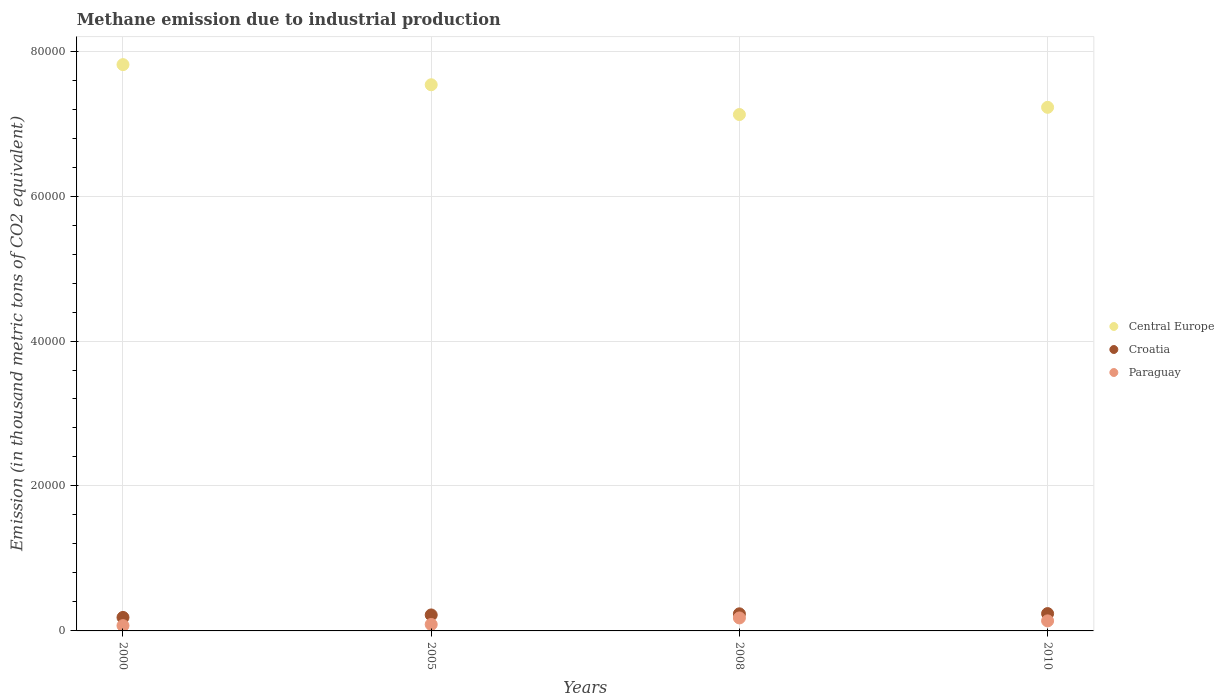Is the number of dotlines equal to the number of legend labels?
Keep it short and to the point. Yes. What is the amount of methane emitted in Croatia in 2005?
Offer a terse response. 2204.5. Across all years, what is the maximum amount of methane emitted in Central Europe?
Offer a terse response. 7.81e+04. Across all years, what is the minimum amount of methane emitted in Central Europe?
Your answer should be compact. 7.12e+04. In which year was the amount of methane emitted in Paraguay minimum?
Provide a short and direct response. 2000. What is the total amount of methane emitted in Croatia in the graph?
Provide a succinct answer. 8814.7. What is the difference between the amount of methane emitted in Paraguay in 2000 and that in 2005?
Your response must be concise. -161.7. What is the difference between the amount of methane emitted in Croatia in 2005 and the amount of methane emitted in Paraguay in 2008?
Your answer should be very brief. 413.8. What is the average amount of methane emitted in Croatia per year?
Offer a very short reply. 2203.68. In the year 2005, what is the difference between the amount of methane emitted in Central Europe and amount of methane emitted in Paraguay?
Your response must be concise. 7.45e+04. In how many years, is the amount of methane emitted in Paraguay greater than 76000 thousand metric tons?
Offer a terse response. 0. What is the ratio of the amount of methane emitted in Croatia in 2005 to that in 2008?
Provide a succinct answer. 0.93. Is the difference between the amount of methane emitted in Central Europe in 2008 and 2010 greater than the difference between the amount of methane emitted in Paraguay in 2008 and 2010?
Provide a short and direct response. No. What is the difference between the highest and the second highest amount of methane emitted in Paraguay?
Make the answer very short. 404.5. What is the difference between the highest and the lowest amount of methane emitted in Croatia?
Your answer should be very brief. 527.6. In how many years, is the amount of methane emitted in Central Europe greater than the average amount of methane emitted in Central Europe taken over all years?
Keep it short and to the point. 2. Does the amount of methane emitted in Paraguay monotonically increase over the years?
Give a very brief answer. No. How many dotlines are there?
Your answer should be compact. 3. What is the difference between two consecutive major ticks on the Y-axis?
Keep it short and to the point. 2.00e+04. Are the values on the major ticks of Y-axis written in scientific E-notation?
Your response must be concise. No. Where does the legend appear in the graph?
Your answer should be compact. Center right. How are the legend labels stacked?
Offer a terse response. Vertical. What is the title of the graph?
Offer a very short reply. Methane emission due to industrial production. What is the label or title of the X-axis?
Your answer should be very brief. Years. What is the label or title of the Y-axis?
Your answer should be very brief. Emission (in thousand metric tons of CO2 equivalent). What is the Emission (in thousand metric tons of CO2 equivalent) in Central Europe in 2000?
Ensure brevity in your answer.  7.81e+04. What is the Emission (in thousand metric tons of CO2 equivalent) of Croatia in 2000?
Your answer should be compact. 1861.7. What is the Emission (in thousand metric tons of CO2 equivalent) in Paraguay in 2000?
Make the answer very short. 730.2. What is the Emission (in thousand metric tons of CO2 equivalent) in Central Europe in 2005?
Give a very brief answer. 7.54e+04. What is the Emission (in thousand metric tons of CO2 equivalent) of Croatia in 2005?
Keep it short and to the point. 2204.5. What is the Emission (in thousand metric tons of CO2 equivalent) in Paraguay in 2005?
Offer a terse response. 891.9. What is the Emission (in thousand metric tons of CO2 equivalent) in Central Europe in 2008?
Provide a short and direct response. 7.12e+04. What is the Emission (in thousand metric tons of CO2 equivalent) of Croatia in 2008?
Make the answer very short. 2359.2. What is the Emission (in thousand metric tons of CO2 equivalent) of Paraguay in 2008?
Keep it short and to the point. 1790.7. What is the Emission (in thousand metric tons of CO2 equivalent) of Central Europe in 2010?
Give a very brief answer. 7.22e+04. What is the Emission (in thousand metric tons of CO2 equivalent) of Croatia in 2010?
Offer a very short reply. 2389.3. What is the Emission (in thousand metric tons of CO2 equivalent) in Paraguay in 2010?
Keep it short and to the point. 1386.2. Across all years, what is the maximum Emission (in thousand metric tons of CO2 equivalent) in Central Europe?
Give a very brief answer. 7.81e+04. Across all years, what is the maximum Emission (in thousand metric tons of CO2 equivalent) in Croatia?
Your response must be concise. 2389.3. Across all years, what is the maximum Emission (in thousand metric tons of CO2 equivalent) in Paraguay?
Make the answer very short. 1790.7. Across all years, what is the minimum Emission (in thousand metric tons of CO2 equivalent) in Central Europe?
Your answer should be very brief. 7.12e+04. Across all years, what is the minimum Emission (in thousand metric tons of CO2 equivalent) of Croatia?
Keep it short and to the point. 1861.7. Across all years, what is the minimum Emission (in thousand metric tons of CO2 equivalent) in Paraguay?
Provide a succinct answer. 730.2. What is the total Emission (in thousand metric tons of CO2 equivalent) of Central Europe in the graph?
Provide a short and direct response. 2.97e+05. What is the total Emission (in thousand metric tons of CO2 equivalent) of Croatia in the graph?
Provide a short and direct response. 8814.7. What is the total Emission (in thousand metric tons of CO2 equivalent) of Paraguay in the graph?
Your response must be concise. 4799. What is the difference between the Emission (in thousand metric tons of CO2 equivalent) in Central Europe in 2000 and that in 2005?
Provide a short and direct response. 2778.4. What is the difference between the Emission (in thousand metric tons of CO2 equivalent) in Croatia in 2000 and that in 2005?
Ensure brevity in your answer.  -342.8. What is the difference between the Emission (in thousand metric tons of CO2 equivalent) in Paraguay in 2000 and that in 2005?
Your answer should be very brief. -161.7. What is the difference between the Emission (in thousand metric tons of CO2 equivalent) of Central Europe in 2000 and that in 2008?
Offer a very short reply. 6887.3. What is the difference between the Emission (in thousand metric tons of CO2 equivalent) in Croatia in 2000 and that in 2008?
Your answer should be compact. -497.5. What is the difference between the Emission (in thousand metric tons of CO2 equivalent) of Paraguay in 2000 and that in 2008?
Ensure brevity in your answer.  -1060.5. What is the difference between the Emission (in thousand metric tons of CO2 equivalent) in Central Europe in 2000 and that in 2010?
Give a very brief answer. 5890.9. What is the difference between the Emission (in thousand metric tons of CO2 equivalent) in Croatia in 2000 and that in 2010?
Offer a terse response. -527.6. What is the difference between the Emission (in thousand metric tons of CO2 equivalent) of Paraguay in 2000 and that in 2010?
Give a very brief answer. -656. What is the difference between the Emission (in thousand metric tons of CO2 equivalent) of Central Europe in 2005 and that in 2008?
Ensure brevity in your answer.  4108.9. What is the difference between the Emission (in thousand metric tons of CO2 equivalent) of Croatia in 2005 and that in 2008?
Provide a succinct answer. -154.7. What is the difference between the Emission (in thousand metric tons of CO2 equivalent) of Paraguay in 2005 and that in 2008?
Offer a terse response. -898.8. What is the difference between the Emission (in thousand metric tons of CO2 equivalent) of Central Europe in 2005 and that in 2010?
Keep it short and to the point. 3112.5. What is the difference between the Emission (in thousand metric tons of CO2 equivalent) in Croatia in 2005 and that in 2010?
Provide a short and direct response. -184.8. What is the difference between the Emission (in thousand metric tons of CO2 equivalent) in Paraguay in 2005 and that in 2010?
Offer a very short reply. -494.3. What is the difference between the Emission (in thousand metric tons of CO2 equivalent) of Central Europe in 2008 and that in 2010?
Offer a terse response. -996.4. What is the difference between the Emission (in thousand metric tons of CO2 equivalent) in Croatia in 2008 and that in 2010?
Offer a terse response. -30.1. What is the difference between the Emission (in thousand metric tons of CO2 equivalent) in Paraguay in 2008 and that in 2010?
Provide a short and direct response. 404.5. What is the difference between the Emission (in thousand metric tons of CO2 equivalent) of Central Europe in 2000 and the Emission (in thousand metric tons of CO2 equivalent) of Croatia in 2005?
Make the answer very short. 7.59e+04. What is the difference between the Emission (in thousand metric tons of CO2 equivalent) in Central Europe in 2000 and the Emission (in thousand metric tons of CO2 equivalent) in Paraguay in 2005?
Offer a very short reply. 7.72e+04. What is the difference between the Emission (in thousand metric tons of CO2 equivalent) of Croatia in 2000 and the Emission (in thousand metric tons of CO2 equivalent) of Paraguay in 2005?
Provide a succinct answer. 969.8. What is the difference between the Emission (in thousand metric tons of CO2 equivalent) of Central Europe in 2000 and the Emission (in thousand metric tons of CO2 equivalent) of Croatia in 2008?
Keep it short and to the point. 7.58e+04. What is the difference between the Emission (in thousand metric tons of CO2 equivalent) in Central Europe in 2000 and the Emission (in thousand metric tons of CO2 equivalent) in Paraguay in 2008?
Provide a short and direct response. 7.63e+04. What is the difference between the Emission (in thousand metric tons of CO2 equivalent) in Central Europe in 2000 and the Emission (in thousand metric tons of CO2 equivalent) in Croatia in 2010?
Ensure brevity in your answer.  7.57e+04. What is the difference between the Emission (in thousand metric tons of CO2 equivalent) in Central Europe in 2000 and the Emission (in thousand metric tons of CO2 equivalent) in Paraguay in 2010?
Give a very brief answer. 7.67e+04. What is the difference between the Emission (in thousand metric tons of CO2 equivalent) of Croatia in 2000 and the Emission (in thousand metric tons of CO2 equivalent) of Paraguay in 2010?
Give a very brief answer. 475.5. What is the difference between the Emission (in thousand metric tons of CO2 equivalent) in Central Europe in 2005 and the Emission (in thousand metric tons of CO2 equivalent) in Croatia in 2008?
Ensure brevity in your answer.  7.30e+04. What is the difference between the Emission (in thousand metric tons of CO2 equivalent) of Central Europe in 2005 and the Emission (in thousand metric tons of CO2 equivalent) of Paraguay in 2008?
Ensure brevity in your answer.  7.36e+04. What is the difference between the Emission (in thousand metric tons of CO2 equivalent) of Croatia in 2005 and the Emission (in thousand metric tons of CO2 equivalent) of Paraguay in 2008?
Ensure brevity in your answer.  413.8. What is the difference between the Emission (in thousand metric tons of CO2 equivalent) of Central Europe in 2005 and the Emission (in thousand metric tons of CO2 equivalent) of Croatia in 2010?
Your response must be concise. 7.30e+04. What is the difference between the Emission (in thousand metric tons of CO2 equivalent) of Central Europe in 2005 and the Emission (in thousand metric tons of CO2 equivalent) of Paraguay in 2010?
Ensure brevity in your answer.  7.40e+04. What is the difference between the Emission (in thousand metric tons of CO2 equivalent) in Croatia in 2005 and the Emission (in thousand metric tons of CO2 equivalent) in Paraguay in 2010?
Offer a very short reply. 818.3. What is the difference between the Emission (in thousand metric tons of CO2 equivalent) in Central Europe in 2008 and the Emission (in thousand metric tons of CO2 equivalent) in Croatia in 2010?
Provide a succinct answer. 6.89e+04. What is the difference between the Emission (in thousand metric tons of CO2 equivalent) of Central Europe in 2008 and the Emission (in thousand metric tons of CO2 equivalent) of Paraguay in 2010?
Provide a succinct answer. 6.99e+04. What is the difference between the Emission (in thousand metric tons of CO2 equivalent) in Croatia in 2008 and the Emission (in thousand metric tons of CO2 equivalent) in Paraguay in 2010?
Make the answer very short. 973. What is the average Emission (in thousand metric tons of CO2 equivalent) in Central Europe per year?
Your response must be concise. 7.42e+04. What is the average Emission (in thousand metric tons of CO2 equivalent) in Croatia per year?
Ensure brevity in your answer.  2203.68. What is the average Emission (in thousand metric tons of CO2 equivalent) of Paraguay per year?
Make the answer very short. 1199.75. In the year 2000, what is the difference between the Emission (in thousand metric tons of CO2 equivalent) of Central Europe and Emission (in thousand metric tons of CO2 equivalent) of Croatia?
Your answer should be compact. 7.63e+04. In the year 2000, what is the difference between the Emission (in thousand metric tons of CO2 equivalent) of Central Europe and Emission (in thousand metric tons of CO2 equivalent) of Paraguay?
Offer a very short reply. 7.74e+04. In the year 2000, what is the difference between the Emission (in thousand metric tons of CO2 equivalent) in Croatia and Emission (in thousand metric tons of CO2 equivalent) in Paraguay?
Ensure brevity in your answer.  1131.5. In the year 2005, what is the difference between the Emission (in thousand metric tons of CO2 equivalent) in Central Europe and Emission (in thousand metric tons of CO2 equivalent) in Croatia?
Your answer should be compact. 7.32e+04. In the year 2005, what is the difference between the Emission (in thousand metric tons of CO2 equivalent) in Central Europe and Emission (in thousand metric tons of CO2 equivalent) in Paraguay?
Keep it short and to the point. 7.45e+04. In the year 2005, what is the difference between the Emission (in thousand metric tons of CO2 equivalent) in Croatia and Emission (in thousand metric tons of CO2 equivalent) in Paraguay?
Keep it short and to the point. 1312.6. In the year 2008, what is the difference between the Emission (in thousand metric tons of CO2 equivalent) of Central Europe and Emission (in thousand metric tons of CO2 equivalent) of Croatia?
Offer a terse response. 6.89e+04. In the year 2008, what is the difference between the Emission (in thousand metric tons of CO2 equivalent) in Central Europe and Emission (in thousand metric tons of CO2 equivalent) in Paraguay?
Your answer should be very brief. 6.95e+04. In the year 2008, what is the difference between the Emission (in thousand metric tons of CO2 equivalent) in Croatia and Emission (in thousand metric tons of CO2 equivalent) in Paraguay?
Make the answer very short. 568.5. In the year 2010, what is the difference between the Emission (in thousand metric tons of CO2 equivalent) in Central Europe and Emission (in thousand metric tons of CO2 equivalent) in Croatia?
Ensure brevity in your answer.  6.99e+04. In the year 2010, what is the difference between the Emission (in thousand metric tons of CO2 equivalent) in Central Europe and Emission (in thousand metric tons of CO2 equivalent) in Paraguay?
Ensure brevity in your answer.  7.09e+04. In the year 2010, what is the difference between the Emission (in thousand metric tons of CO2 equivalent) of Croatia and Emission (in thousand metric tons of CO2 equivalent) of Paraguay?
Make the answer very short. 1003.1. What is the ratio of the Emission (in thousand metric tons of CO2 equivalent) of Central Europe in 2000 to that in 2005?
Keep it short and to the point. 1.04. What is the ratio of the Emission (in thousand metric tons of CO2 equivalent) in Croatia in 2000 to that in 2005?
Make the answer very short. 0.84. What is the ratio of the Emission (in thousand metric tons of CO2 equivalent) in Paraguay in 2000 to that in 2005?
Keep it short and to the point. 0.82. What is the ratio of the Emission (in thousand metric tons of CO2 equivalent) in Central Europe in 2000 to that in 2008?
Your answer should be compact. 1.1. What is the ratio of the Emission (in thousand metric tons of CO2 equivalent) in Croatia in 2000 to that in 2008?
Make the answer very short. 0.79. What is the ratio of the Emission (in thousand metric tons of CO2 equivalent) of Paraguay in 2000 to that in 2008?
Ensure brevity in your answer.  0.41. What is the ratio of the Emission (in thousand metric tons of CO2 equivalent) in Central Europe in 2000 to that in 2010?
Offer a very short reply. 1.08. What is the ratio of the Emission (in thousand metric tons of CO2 equivalent) in Croatia in 2000 to that in 2010?
Your answer should be very brief. 0.78. What is the ratio of the Emission (in thousand metric tons of CO2 equivalent) in Paraguay in 2000 to that in 2010?
Offer a very short reply. 0.53. What is the ratio of the Emission (in thousand metric tons of CO2 equivalent) in Central Europe in 2005 to that in 2008?
Provide a succinct answer. 1.06. What is the ratio of the Emission (in thousand metric tons of CO2 equivalent) of Croatia in 2005 to that in 2008?
Your answer should be compact. 0.93. What is the ratio of the Emission (in thousand metric tons of CO2 equivalent) of Paraguay in 2005 to that in 2008?
Provide a succinct answer. 0.5. What is the ratio of the Emission (in thousand metric tons of CO2 equivalent) of Central Europe in 2005 to that in 2010?
Provide a succinct answer. 1.04. What is the ratio of the Emission (in thousand metric tons of CO2 equivalent) in Croatia in 2005 to that in 2010?
Ensure brevity in your answer.  0.92. What is the ratio of the Emission (in thousand metric tons of CO2 equivalent) in Paraguay in 2005 to that in 2010?
Give a very brief answer. 0.64. What is the ratio of the Emission (in thousand metric tons of CO2 equivalent) of Central Europe in 2008 to that in 2010?
Your answer should be compact. 0.99. What is the ratio of the Emission (in thousand metric tons of CO2 equivalent) of Croatia in 2008 to that in 2010?
Provide a succinct answer. 0.99. What is the ratio of the Emission (in thousand metric tons of CO2 equivalent) in Paraguay in 2008 to that in 2010?
Provide a succinct answer. 1.29. What is the difference between the highest and the second highest Emission (in thousand metric tons of CO2 equivalent) in Central Europe?
Provide a succinct answer. 2778.4. What is the difference between the highest and the second highest Emission (in thousand metric tons of CO2 equivalent) of Croatia?
Offer a terse response. 30.1. What is the difference between the highest and the second highest Emission (in thousand metric tons of CO2 equivalent) of Paraguay?
Your answer should be very brief. 404.5. What is the difference between the highest and the lowest Emission (in thousand metric tons of CO2 equivalent) in Central Europe?
Keep it short and to the point. 6887.3. What is the difference between the highest and the lowest Emission (in thousand metric tons of CO2 equivalent) of Croatia?
Keep it short and to the point. 527.6. What is the difference between the highest and the lowest Emission (in thousand metric tons of CO2 equivalent) of Paraguay?
Offer a terse response. 1060.5. 